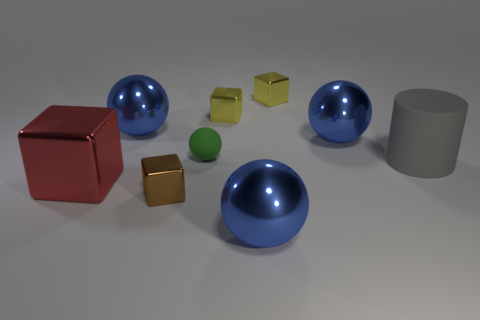The big cylinder is what color?
Offer a terse response. Gray. What is the size of the other brown block that is made of the same material as the big block?
Your response must be concise. Small. Is there a rubber ball of the same color as the big cube?
Keep it short and to the point. No. How many things are small brown blocks that are in front of the green object or large red metallic spheres?
Provide a short and direct response. 1. Are the small green ball and the gray cylinder in front of the small green matte ball made of the same material?
Offer a terse response. Yes. Is there a yellow cube made of the same material as the brown thing?
Give a very brief answer. Yes. How many objects are either large blue metallic spheres in front of the large red shiny block or blue metallic things that are in front of the large red metal thing?
Your answer should be compact. 1. Is the shape of the small brown object the same as the blue thing that is in front of the tiny brown object?
Provide a succinct answer. No. What number of other objects are there of the same shape as the large red object?
Provide a short and direct response. 3. What number of things are either big brown matte balls or cylinders?
Your response must be concise. 1. 